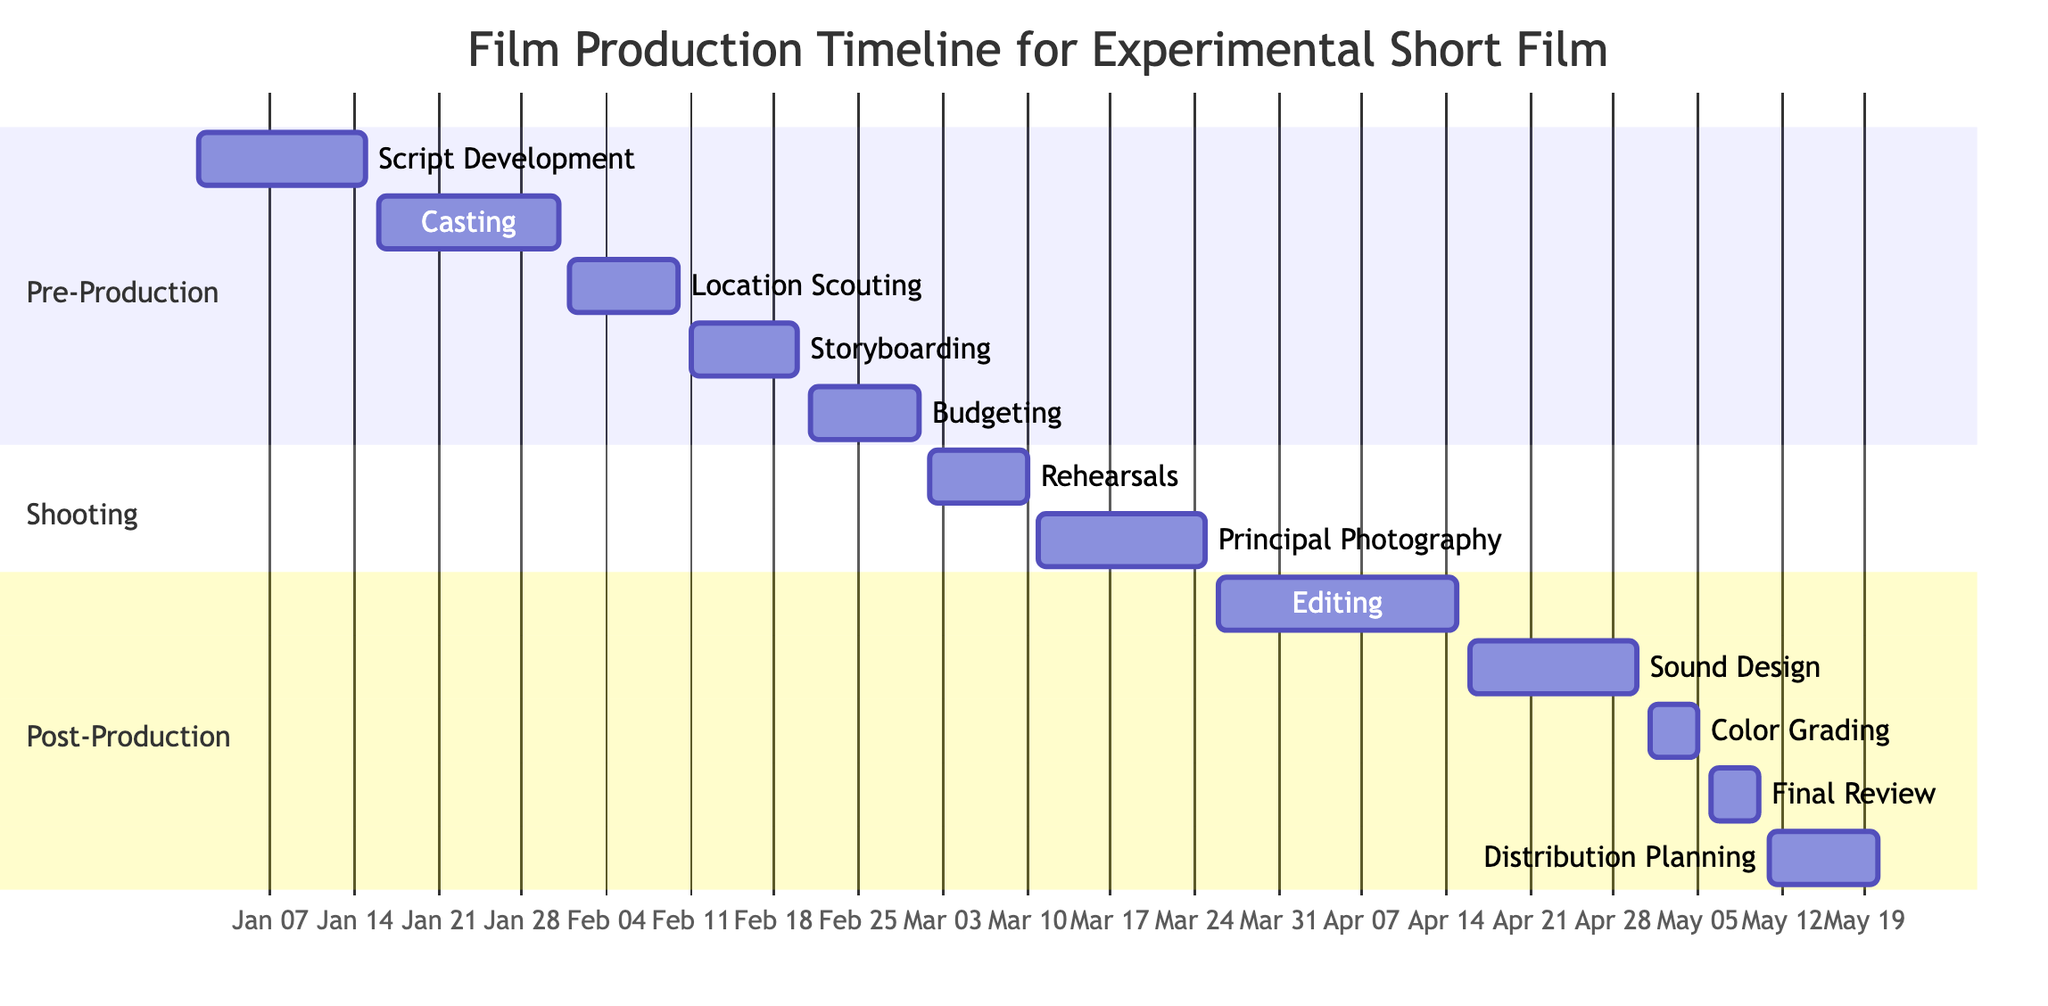What is the duration of the Script Development phase? The Script Development phase starts on January 1, 2024, and ends on January 15, 2024. The duration can be calculated as the difference between the start and end dates, which is 15 days.
Answer: 15 days Which phase comes after Casting? The phases are organized in a sequential order under the Pre-Production section. After Casting, the next activity listed is Location Scouting, which starts on February 1, 2024.
Answer: Location Scouting How many activities are in the Shooting phase? In the Shooting section, there are two activities: Rehearsals and Principal Photography. Counting these gives a total of 2 activities in that phase.
Answer: 2 activities What are the start and end dates for Sound Design? The Sound Design activity starts on April 16, 2024, and ends on April 30, 2024. These specific dates can be found under the Post-Production section for the respective task.
Answer: April 16, 2024 to April 30, 2024 Which activity has the latest start date in the Gantt chart? The latest start date is for Distribution Planning, which begins on May 11, 2024. By comparing the start dates of all activities, this date is identified as the most recent.
Answer: May 11, 2024 During which phase does the Final Review take place? The Final Review is listed under the Post-Production section of the Gantt chart. This phase occurs after editing and sound design, focusing on final adjustments.
Answer: Post-Production What is the total duration of the Post-Production phase including all activities? The Post-Production phase includes multiple activities: Editing lasts from March 26 to April 15 (20 days), Sound Design from April 16 to April 30 (15 days), Color Grading from May 1 to May 5 (5 days), Final Review from May 6 to May 10 (5 days), and Distribution Planning from May 11 to May 20 (10 days). Adding these durations together equals 55 days total for the Post-Production phase.
Answer: 55 days Which activity overlaps with Color Grading? The Final Review overlaps with Color Grading since it starts on May 6, 2024, while Color Grading is still ongoing up until May 5, 2024. As per the defined durations, these two activities do not overlap in execution time, thus identifying any parallel activity leads to a significant understanding of sequence.
Answer: None What is the total timeline of the entire production process? The overall timeline spans from January 1, 2024 (start of Script Development), to May 20, 2024 (end of Distribution Planning). This gives a total duration from the start of Pre-Production to the completion of Post-Production. The calculation from these two points defines the entire timeline in days.
Answer: 140 days 